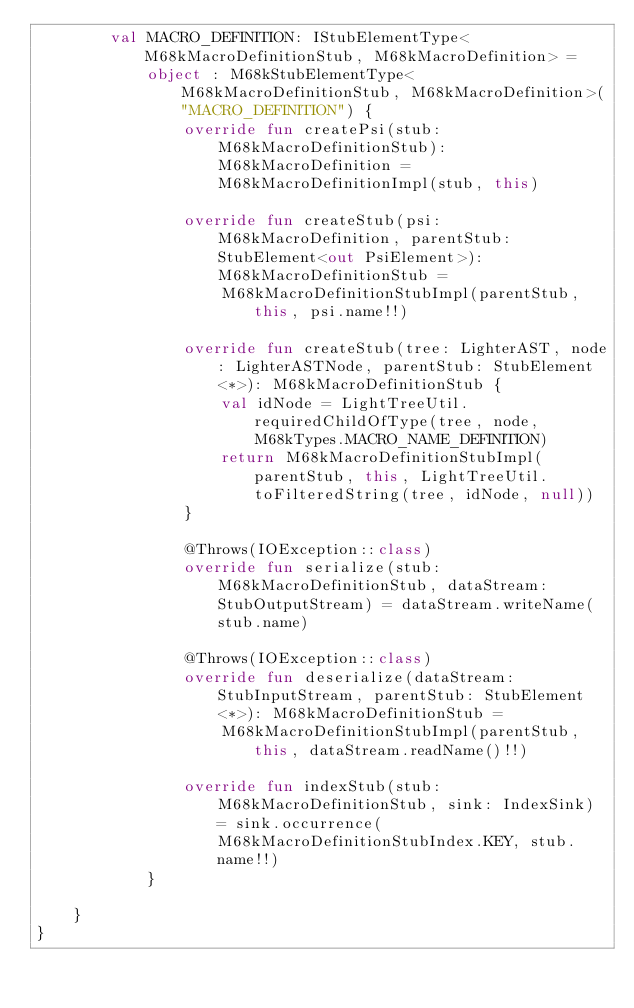Convert code to text. <code><loc_0><loc_0><loc_500><loc_500><_Kotlin_>        val MACRO_DEFINITION: IStubElementType<M68kMacroDefinitionStub, M68kMacroDefinition> =
            object : M68kStubElementType<M68kMacroDefinitionStub, M68kMacroDefinition>("MACRO_DEFINITION") {
                override fun createPsi(stub: M68kMacroDefinitionStub): M68kMacroDefinition = M68kMacroDefinitionImpl(stub, this)

                override fun createStub(psi: M68kMacroDefinition, parentStub: StubElement<out PsiElement>): M68kMacroDefinitionStub =
                    M68kMacroDefinitionStubImpl(parentStub, this, psi.name!!)

                override fun createStub(tree: LighterAST, node: LighterASTNode, parentStub: StubElement<*>): M68kMacroDefinitionStub {
                    val idNode = LightTreeUtil.requiredChildOfType(tree, node, M68kTypes.MACRO_NAME_DEFINITION)
                    return M68kMacroDefinitionStubImpl(parentStub, this, LightTreeUtil.toFilteredString(tree, idNode, null))
                }

                @Throws(IOException::class)
                override fun serialize(stub: M68kMacroDefinitionStub, dataStream: StubOutputStream) = dataStream.writeName(stub.name)

                @Throws(IOException::class)
                override fun deserialize(dataStream: StubInputStream, parentStub: StubElement<*>): M68kMacroDefinitionStub =
                    M68kMacroDefinitionStubImpl(parentStub, this, dataStream.readName()!!)

                override fun indexStub(stub: M68kMacroDefinitionStub, sink: IndexSink) = sink.occurrence(M68kMacroDefinitionStubIndex.KEY, stub.name!!)
            }

    }
}</code> 